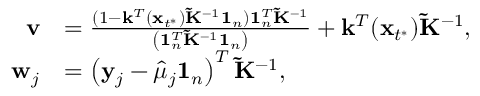Convert formula to latex. <formula><loc_0><loc_0><loc_500><loc_500>\begin{array} { r l } { v } & { = \frac { ( 1 - \mathbf k ^ { T } ( \mathbf x _ { t ^ { * } } ) \tilde { K } ^ { - 1 } \mathbf 1 _ { n } ) 1 _ { n } ^ { T } { \tilde { K } } ^ { - 1 } } { \left ( 1 _ { n } ^ { T } { \tilde { K } } ^ { - 1 } 1 _ { n } \right ) } + \mathbf k ^ { T } ( \mathbf x _ { t ^ { * } } ) \tilde { K } ^ { - 1 } , } \\ { w _ { j } } & { = \left ( y _ { j } - \hat { \mu } _ { j } 1 _ { n } \right ) ^ { T } \tilde { K } ^ { - 1 } , } \end{array}</formula> 